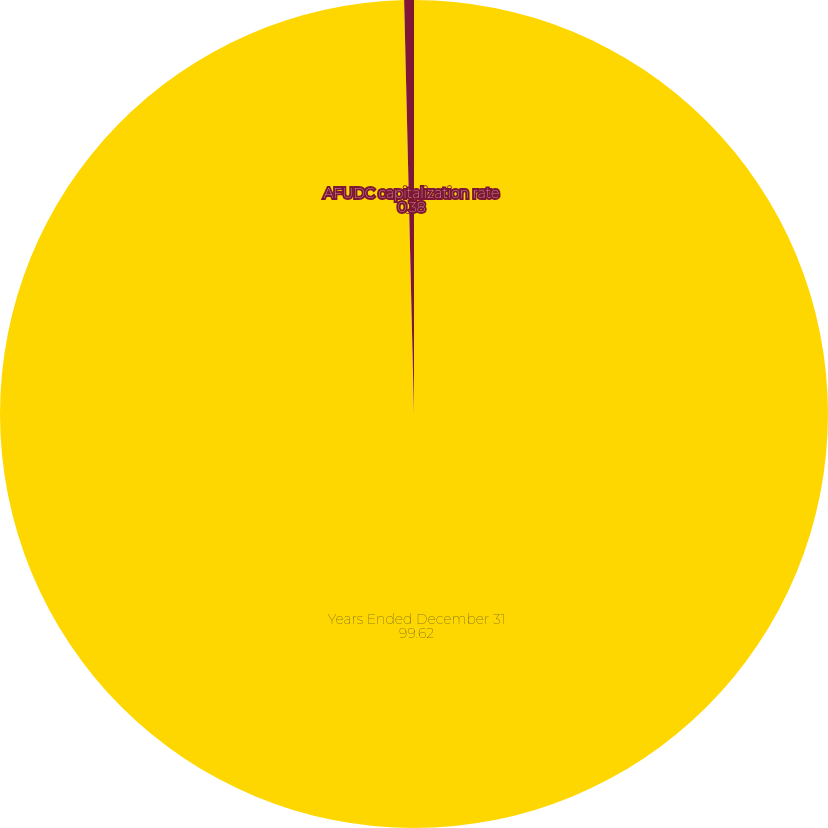Convert chart to OTSL. <chart><loc_0><loc_0><loc_500><loc_500><pie_chart><fcel>Years Ended December 31<fcel>AFUDC capitalization rate<nl><fcel>99.62%<fcel>0.38%<nl></chart> 